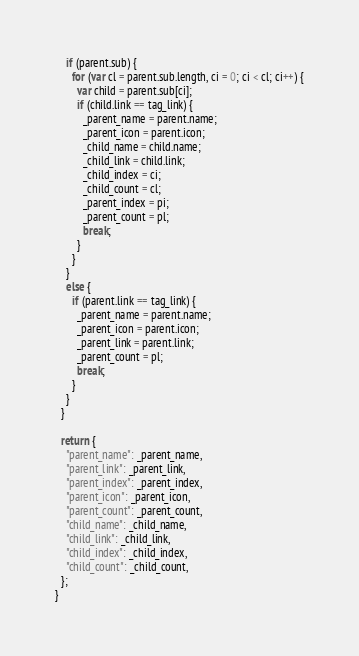<code> <loc_0><loc_0><loc_500><loc_500><_JavaScript_>    if (parent.sub) {
      for (var cl = parent.sub.length, ci = 0; ci < cl; ci++) {
        var child = parent.sub[ci];
        if (child.link == tag_link) {
          _parent_name = parent.name;
          _parent_icon = parent.icon;
          _child_name = child.name;
          _child_link = child.link;
          _child_index = ci;
          _child_count = cl;
          _parent_index = pi; 
          _parent_count = pl; 
          break;
        }
      }
    }
    else {
      if (parent.link == tag_link) {
        _parent_name = parent.name;
        _parent_icon = parent.icon;
        _parent_link = parent.link;
        _parent_count = pl; 
        break;
      }
    }
  }

  return {
    "parent_name": _parent_name,
    "parent_link": _parent_link,
    "parent_index": _parent_index,
    "parent_icon": _parent_icon,
    "parent_count": _parent_count,
    "child_name": _child_name,
    "child_link": _child_link,
    "child_index": _child_index,
    "child_count": _child_count,
  };
}
</code> 